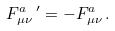Convert formula to latex. <formula><loc_0><loc_0><loc_500><loc_500>F ^ { a } _ { \mu \nu } \, ^ { \prime } = - F ^ { a } _ { \mu \nu } \, .</formula> 